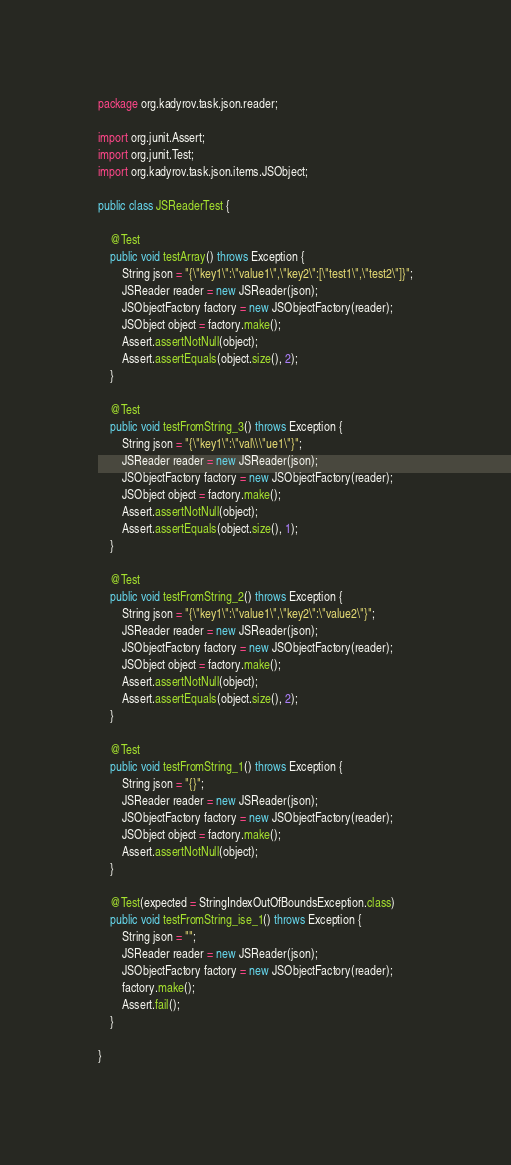Convert code to text. <code><loc_0><loc_0><loc_500><loc_500><_Java_>package org.kadyrov.task.json.reader;

import org.junit.Assert;
import org.junit.Test;
import org.kadyrov.task.json.items.JSObject;

public class JSReaderTest {

    @Test
    public void testArray() throws Exception {
        String json = "{\"key1\":\"value1\",\"key2\":[\"test1\",\"test2\"]}";
        JSReader reader = new JSReader(json);
        JSObjectFactory factory = new JSObjectFactory(reader);
        JSObject object = factory.make();
        Assert.assertNotNull(object);
        Assert.assertEquals(object.size(), 2);
    }

    @Test
    public void testFromString_3() throws Exception {
        String json = "{\"key1\":\"val\\\"ue1\"}";
        JSReader reader = new JSReader(json);
        JSObjectFactory factory = new JSObjectFactory(reader);
        JSObject object = factory.make();
        Assert.assertNotNull(object);
        Assert.assertEquals(object.size(), 1);
    }

    @Test
    public void testFromString_2() throws Exception {
        String json = "{\"key1\":\"value1\",\"key2\":\"value2\"}";
        JSReader reader = new JSReader(json);
        JSObjectFactory factory = new JSObjectFactory(reader);
        JSObject object = factory.make();
        Assert.assertNotNull(object);
        Assert.assertEquals(object.size(), 2);
    }

    @Test
    public void testFromString_1() throws Exception {
        String json = "{}";
        JSReader reader = new JSReader(json);
        JSObjectFactory factory = new JSObjectFactory(reader);
        JSObject object = factory.make();
        Assert.assertNotNull(object);
    }

    @Test(expected = StringIndexOutOfBoundsException.class)
    public void testFromString_ise_1() throws Exception {
        String json = "";
        JSReader reader = new JSReader(json);
        JSObjectFactory factory = new JSObjectFactory(reader);
        factory.make();
        Assert.fail();
    }
    
}
</code> 